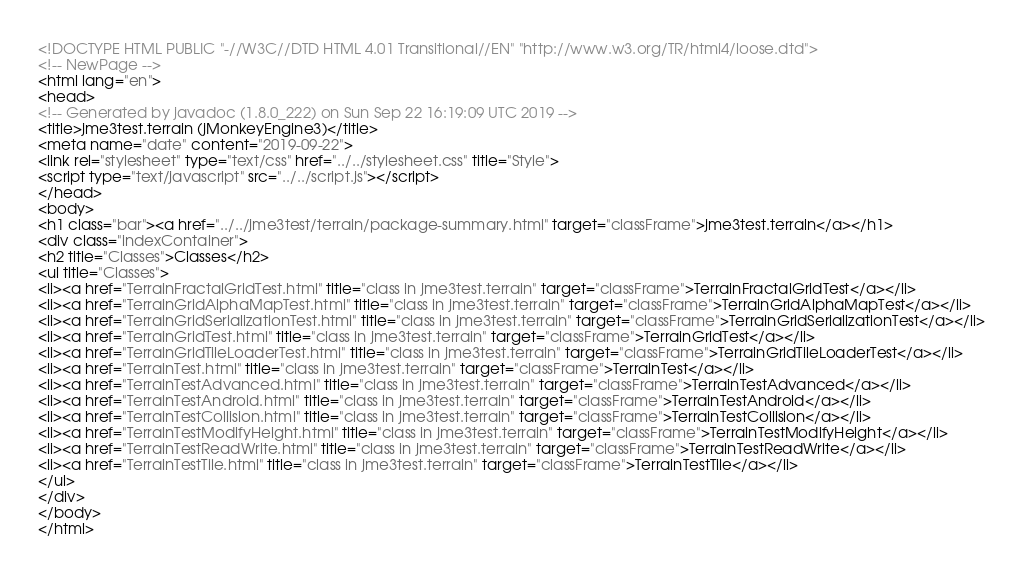Convert code to text. <code><loc_0><loc_0><loc_500><loc_500><_HTML_><!DOCTYPE HTML PUBLIC "-//W3C//DTD HTML 4.01 Transitional//EN" "http://www.w3.org/TR/html4/loose.dtd">
<!-- NewPage -->
<html lang="en">
<head>
<!-- Generated by javadoc (1.8.0_222) on Sun Sep 22 16:19:09 UTC 2019 -->
<title>jme3test.terrain (jMonkeyEngine3)</title>
<meta name="date" content="2019-09-22">
<link rel="stylesheet" type="text/css" href="../../stylesheet.css" title="Style">
<script type="text/javascript" src="../../script.js"></script>
</head>
<body>
<h1 class="bar"><a href="../../jme3test/terrain/package-summary.html" target="classFrame">jme3test.terrain</a></h1>
<div class="indexContainer">
<h2 title="Classes">Classes</h2>
<ul title="Classes">
<li><a href="TerrainFractalGridTest.html" title="class in jme3test.terrain" target="classFrame">TerrainFractalGridTest</a></li>
<li><a href="TerrainGridAlphaMapTest.html" title="class in jme3test.terrain" target="classFrame">TerrainGridAlphaMapTest</a></li>
<li><a href="TerrainGridSerializationTest.html" title="class in jme3test.terrain" target="classFrame">TerrainGridSerializationTest</a></li>
<li><a href="TerrainGridTest.html" title="class in jme3test.terrain" target="classFrame">TerrainGridTest</a></li>
<li><a href="TerrainGridTileLoaderTest.html" title="class in jme3test.terrain" target="classFrame">TerrainGridTileLoaderTest</a></li>
<li><a href="TerrainTest.html" title="class in jme3test.terrain" target="classFrame">TerrainTest</a></li>
<li><a href="TerrainTestAdvanced.html" title="class in jme3test.terrain" target="classFrame">TerrainTestAdvanced</a></li>
<li><a href="TerrainTestAndroid.html" title="class in jme3test.terrain" target="classFrame">TerrainTestAndroid</a></li>
<li><a href="TerrainTestCollision.html" title="class in jme3test.terrain" target="classFrame">TerrainTestCollision</a></li>
<li><a href="TerrainTestModifyHeight.html" title="class in jme3test.terrain" target="classFrame">TerrainTestModifyHeight</a></li>
<li><a href="TerrainTestReadWrite.html" title="class in jme3test.terrain" target="classFrame">TerrainTestReadWrite</a></li>
<li><a href="TerrainTestTile.html" title="class in jme3test.terrain" target="classFrame">TerrainTestTile</a></li>
</ul>
</div>
</body>
</html>
</code> 